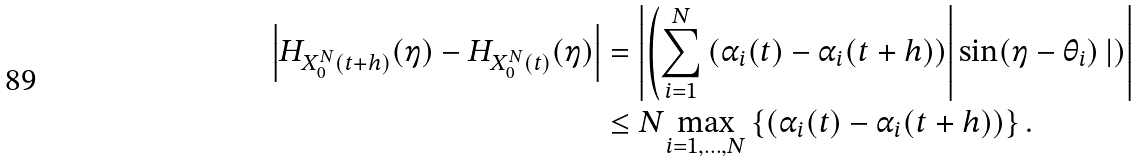Convert formula to latex. <formula><loc_0><loc_0><loc_500><loc_500>\left | H _ { X _ { 0 } ^ { N } ( t + h ) } ( \eta ) - H _ { X _ { 0 } ^ { N } ( t ) } ( \eta ) \right | & = \left | \left ( \sum _ { i = 1 } ^ { N } \left ( \alpha _ { i } ( t ) - \alpha _ { i } ( t + h ) \right ) \right | \sin ( \eta - \theta _ { i } ) \left | \right ) \right | \\ & \leq N \underset { i = 1 , \dots , N } { \max } \left \{ \left ( \alpha _ { i } ( t ) - \alpha _ { i } ( t + h ) \right ) \right \} .</formula> 